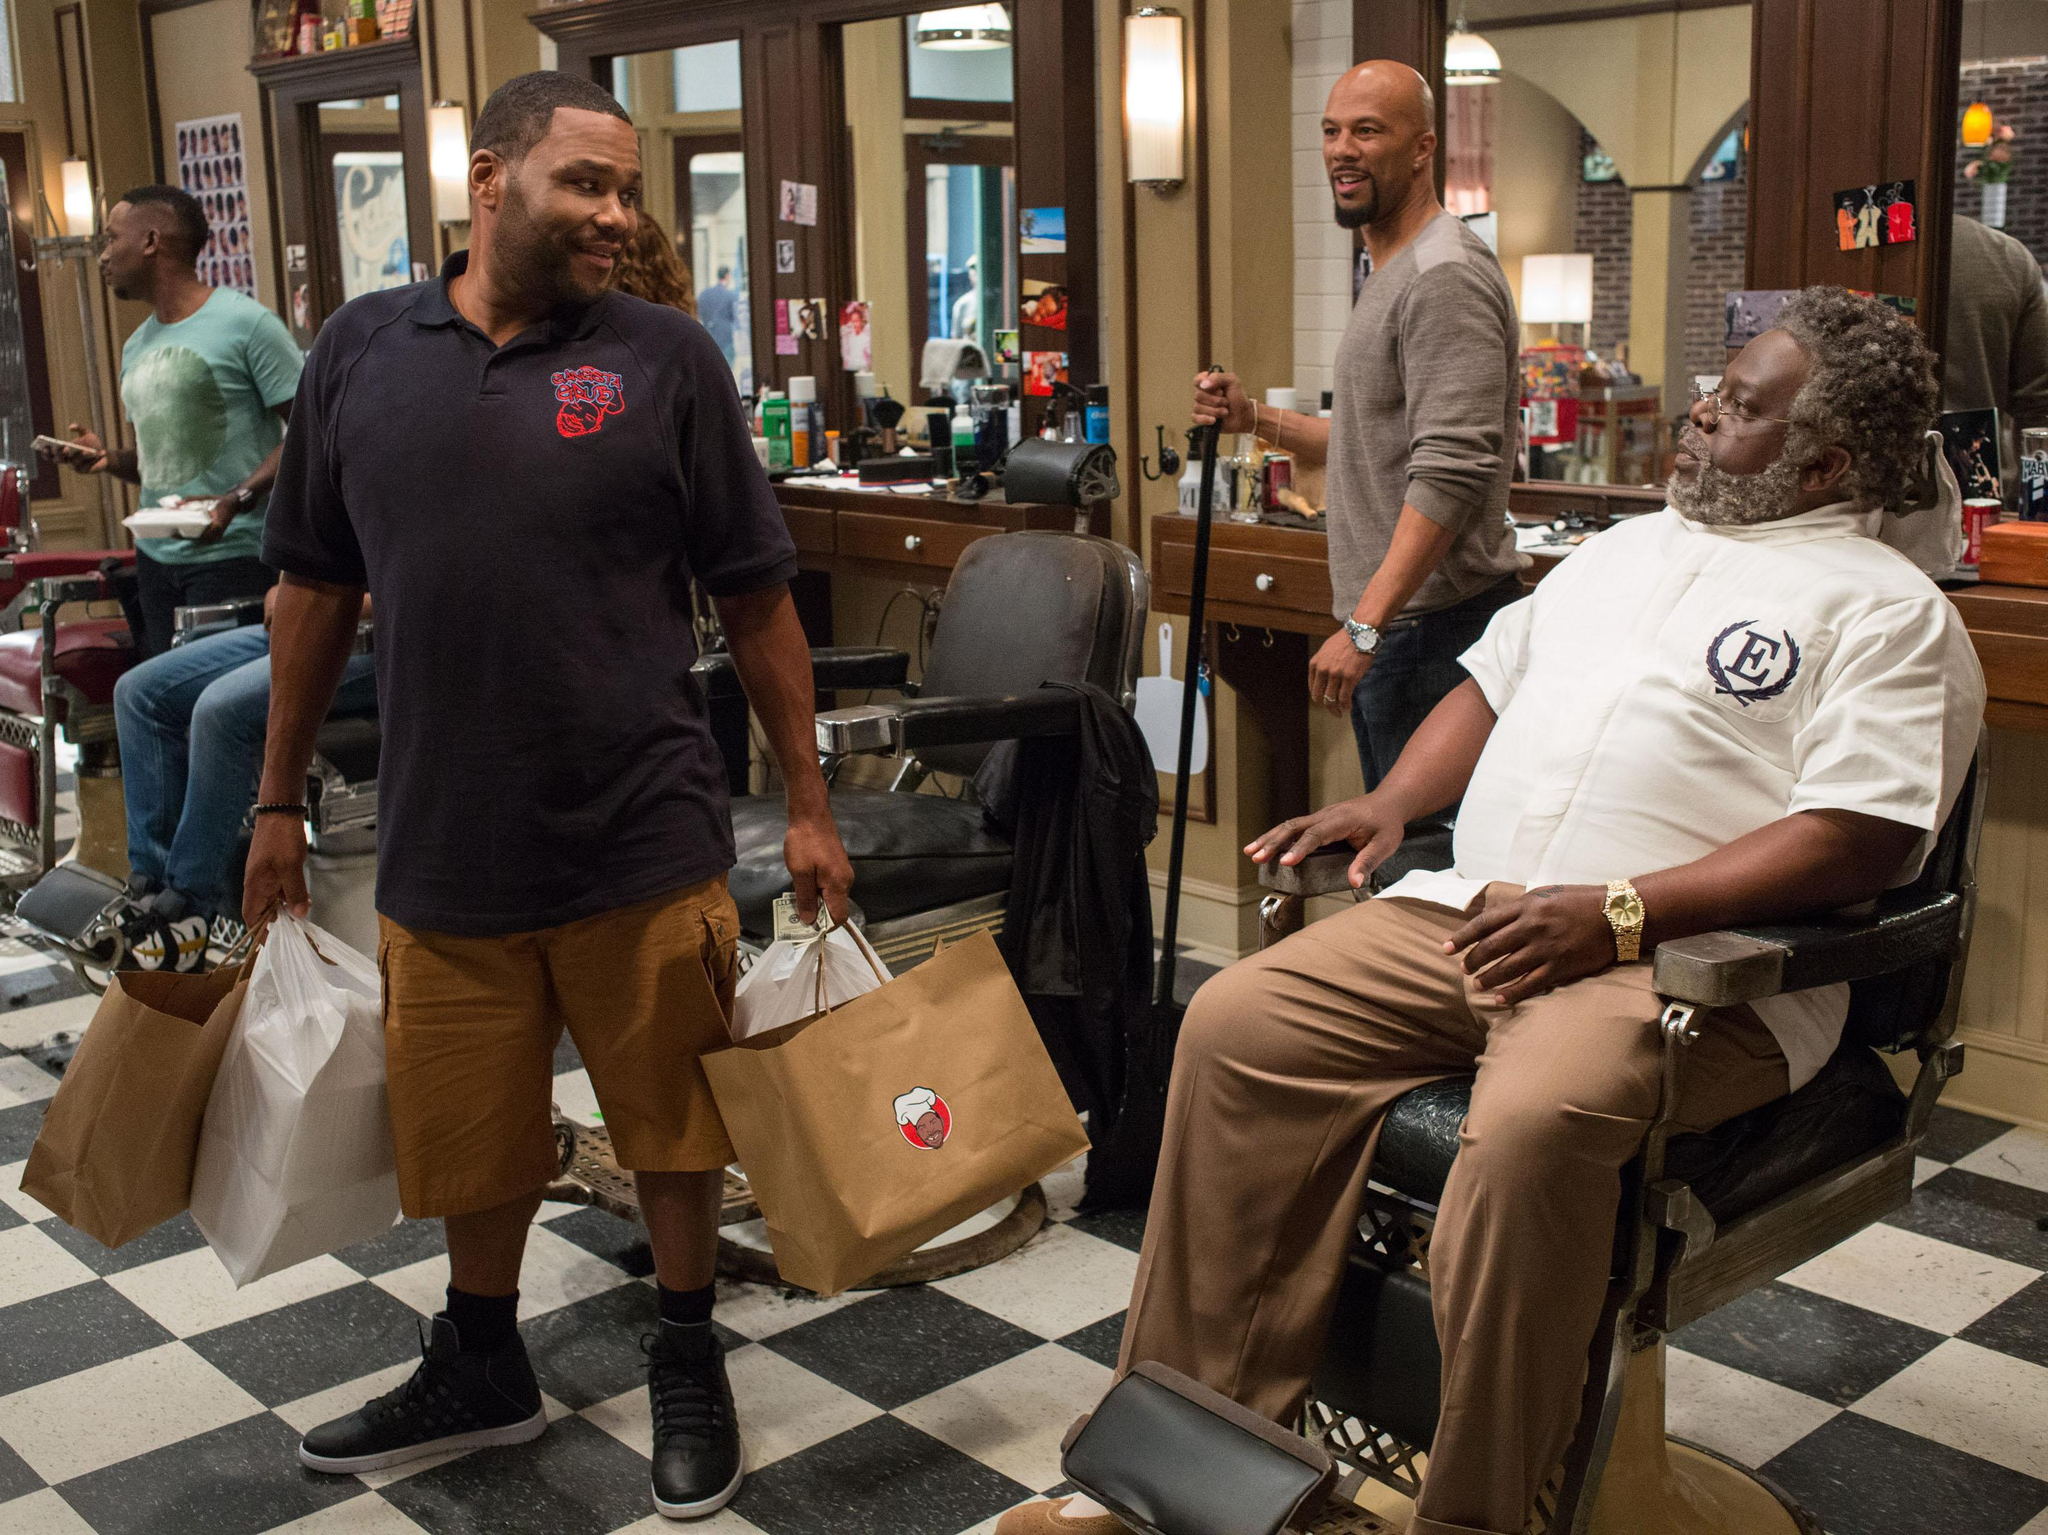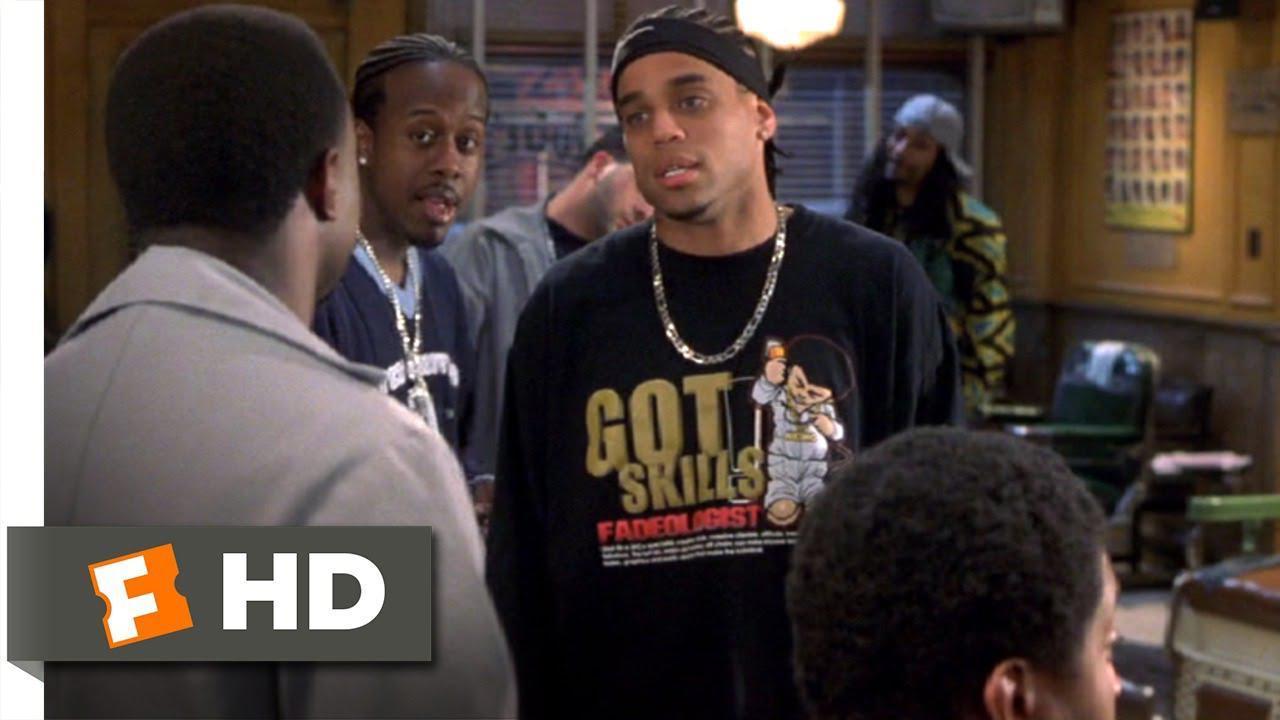The first image is the image on the left, the second image is the image on the right. Assess this claim about the two images: "An image includes a woman wearing red top and stars-and-stripes bottoms.". Correct or not? Answer yes or no. No. The first image is the image on the left, the second image is the image on the right. Analyze the images presented: Is the assertion "In one image, a large barber shop mural is on a back wall beside a door." valid? Answer yes or no. No. 